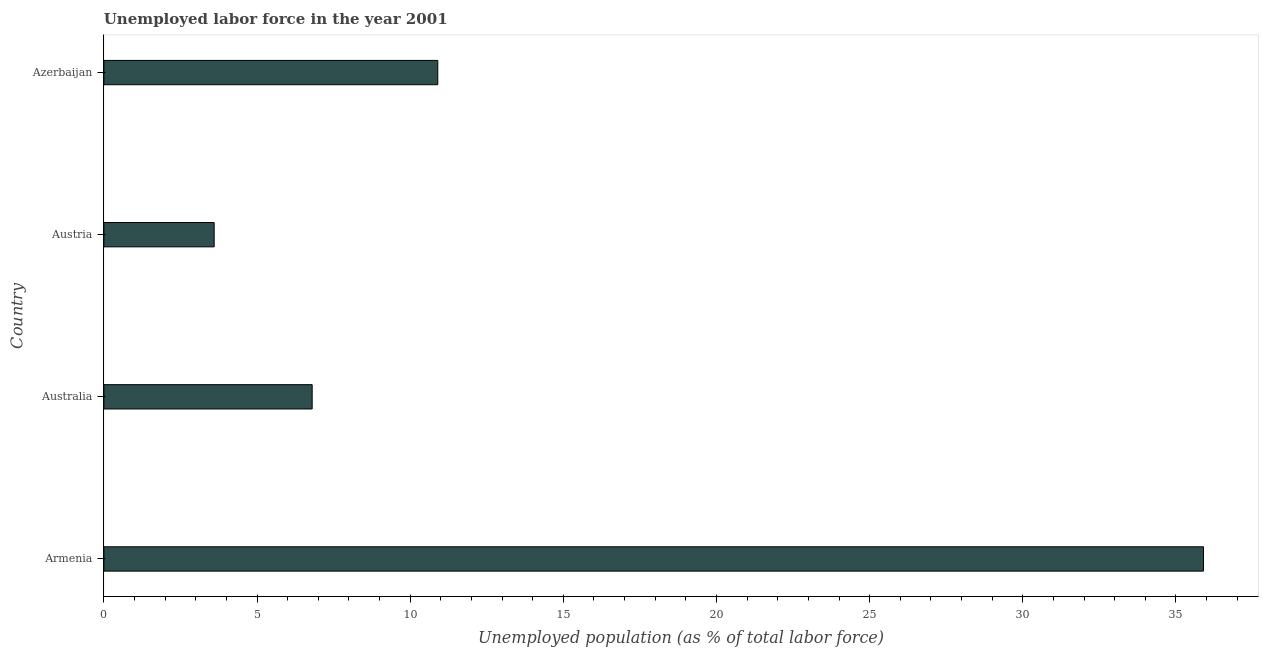Does the graph contain grids?
Ensure brevity in your answer.  No. What is the title of the graph?
Offer a terse response. Unemployed labor force in the year 2001. What is the label or title of the X-axis?
Offer a very short reply. Unemployed population (as % of total labor force). What is the label or title of the Y-axis?
Make the answer very short. Country. What is the total unemployed population in Azerbaijan?
Offer a very short reply. 10.9. Across all countries, what is the maximum total unemployed population?
Give a very brief answer. 35.9. Across all countries, what is the minimum total unemployed population?
Offer a very short reply. 3.6. In which country was the total unemployed population maximum?
Offer a terse response. Armenia. What is the sum of the total unemployed population?
Ensure brevity in your answer.  57.2. What is the median total unemployed population?
Offer a terse response. 8.85. What is the ratio of the total unemployed population in Armenia to that in Austria?
Your answer should be very brief. 9.97. Is the total unemployed population in Austria less than that in Azerbaijan?
Provide a short and direct response. Yes. What is the difference between the highest and the second highest total unemployed population?
Ensure brevity in your answer.  25. What is the difference between the highest and the lowest total unemployed population?
Provide a short and direct response. 32.3. How many bars are there?
Provide a short and direct response. 4. Are all the bars in the graph horizontal?
Give a very brief answer. Yes. What is the difference between two consecutive major ticks on the X-axis?
Provide a short and direct response. 5. What is the Unemployed population (as % of total labor force) of Armenia?
Make the answer very short. 35.9. What is the Unemployed population (as % of total labor force) in Australia?
Keep it short and to the point. 6.8. What is the Unemployed population (as % of total labor force) of Austria?
Your answer should be compact. 3.6. What is the Unemployed population (as % of total labor force) of Azerbaijan?
Provide a succinct answer. 10.9. What is the difference between the Unemployed population (as % of total labor force) in Armenia and Australia?
Provide a succinct answer. 29.1. What is the difference between the Unemployed population (as % of total labor force) in Armenia and Austria?
Your answer should be very brief. 32.3. What is the difference between the Unemployed population (as % of total labor force) in Armenia and Azerbaijan?
Offer a terse response. 25. What is the difference between the Unemployed population (as % of total labor force) in Australia and Austria?
Keep it short and to the point. 3.2. What is the difference between the Unemployed population (as % of total labor force) in Austria and Azerbaijan?
Make the answer very short. -7.3. What is the ratio of the Unemployed population (as % of total labor force) in Armenia to that in Australia?
Your answer should be very brief. 5.28. What is the ratio of the Unemployed population (as % of total labor force) in Armenia to that in Austria?
Offer a terse response. 9.97. What is the ratio of the Unemployed population (as % of total labor force) in Armenia to that in Azerbaijan?
Offer a very short reply. 3.29. What is the ratio of the Unemployed population (as % of total labor force) in Australia to that in Austria?
Your answer should be compact. 1.89. What is the ratio of the Unemployed population (as % of total labor force) in Australia to that in Azerbaijan?
Your answer should be compact. 0.62. What is the ratio of the Unemployed population (as % of total labor force) in Austria to that in Azerbaijan?
Your response must be concise. 0.33. 